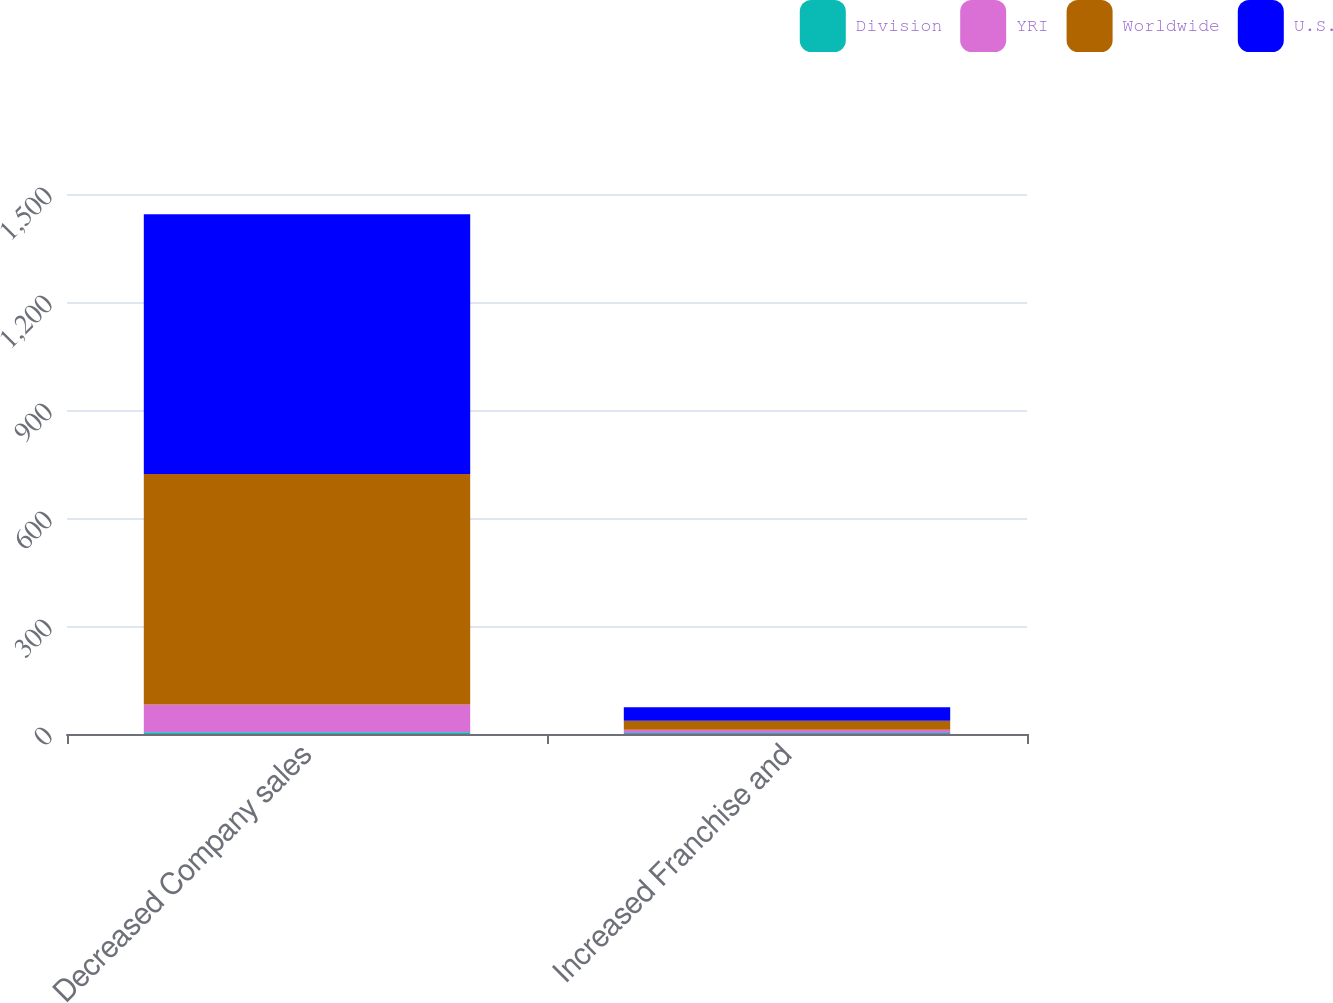Convert chart. <chart><loc_0><loc_0><loc_500><loc_500><stacked_bar_chart><ecel><fcel>Decreased Company sales<fcel>Increased Franchise and<nl><fcel>Division<fcel>5<fcel>3<nl><fcel>YRI<fcel>77<fcel>9<nl><fcel>Worldwide<fcel>640<fcel>25<nl><fcel>U.S.<fcel>722<fcel>37<nl></chart> 